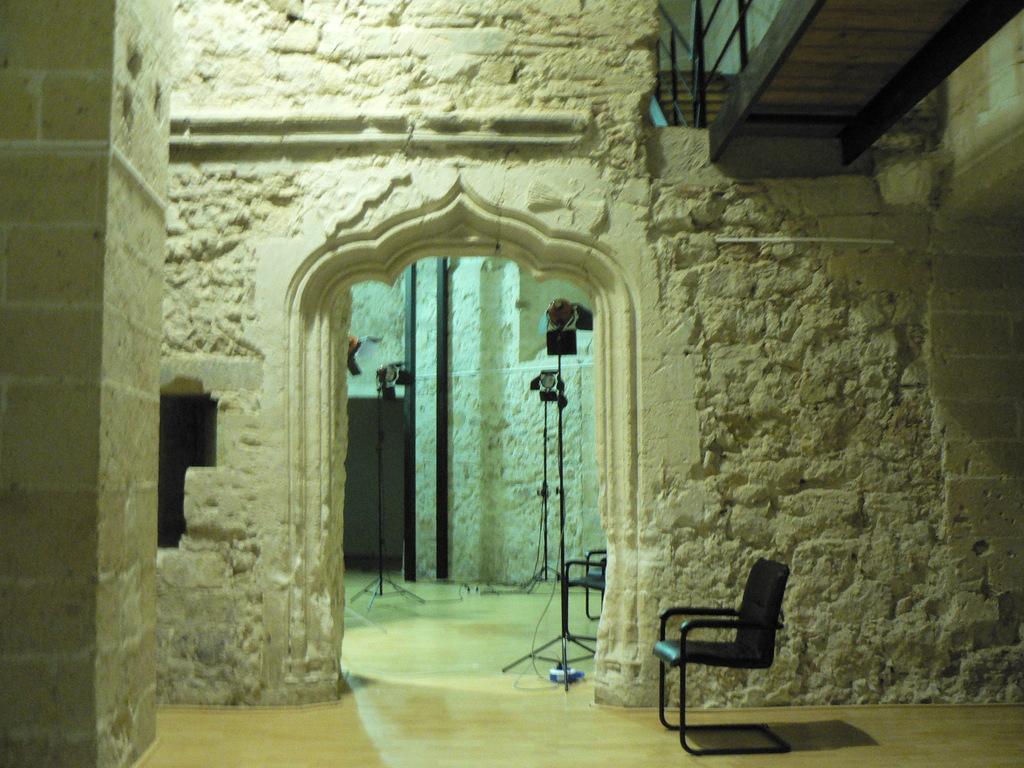In one or two sentences, can you explain what this image depicts? In this image, we can see a building and there are stands, a chair and a railing. At the bottom, there is an object on the floor. 